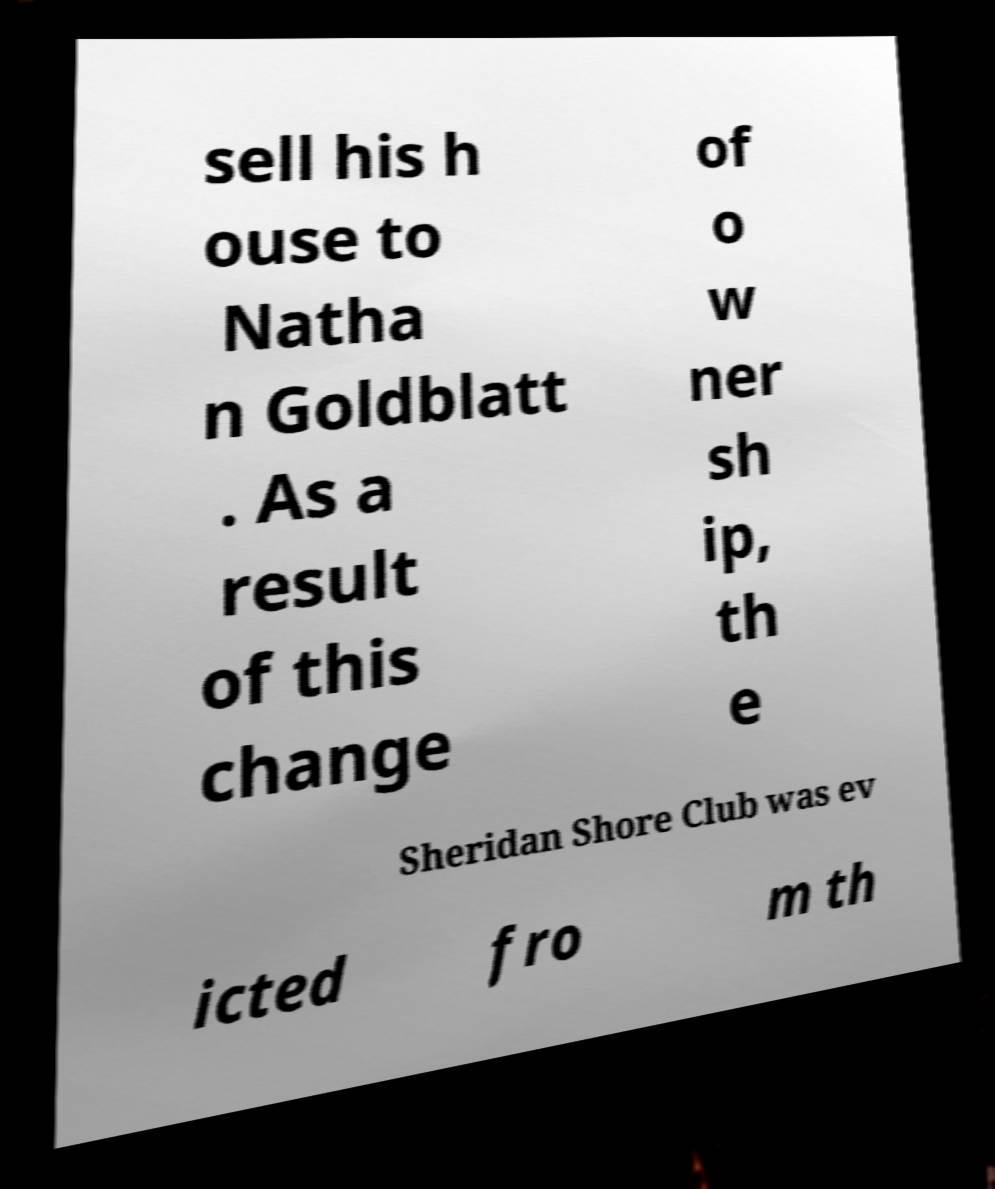Please identify and transcribe the text found in this image. sell his h ouse to Natha n Goldblatt . As a result of this change of o w ner sh ip, th e Sheridan Shore Club was ev icted fro m th 